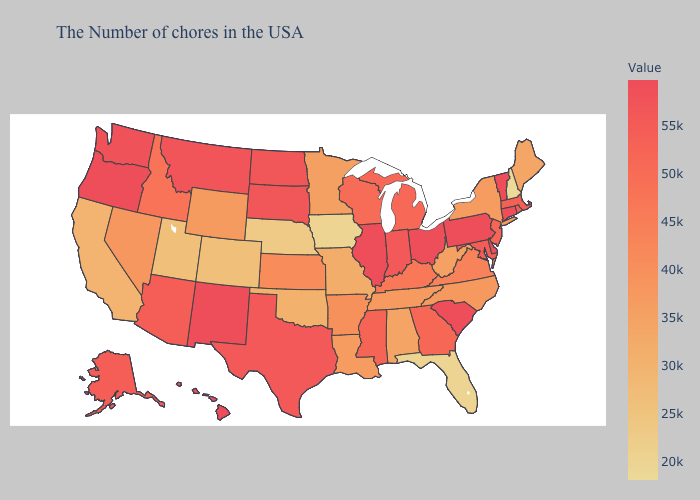Does Alaska have a higher value than Ohio?
Short answer required. No. Does Iowa have the lowest value in the MidWest?
Give a very brief answer. Yes. Is the legend a continuous bar?
Short answer required. Yes. Among the states that border Michigan , does Ohio have the highest value?
Concise answer only. Yes. Which states hav the highest value in the South?
Quick response, please. South Carolina. 